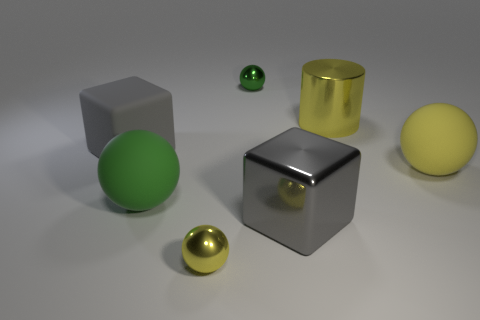How many other big yellow cylinders have the same material as the cylinder?
Provide a short and direct response. 0. There is another green metallic thing that is the same shape as the large green object; what is its size?
Offer a very short reply. Small. Are there any large cubes in front of the tiny yellow object?
Offer a terse response. No. What material is the big green ball?
Give a very brief answer. Rubber. Is the color of the tiny thing in front of the big gray metallic block the same as the big matte block?
Make the answer very short. No. Is there anything else that has the same shape as the large green rubber thing?
Make the answer very short. Yes. There is another big rubber object that is the same shape as the big yellow rubber thing; what is its color?
Offer a very short reply. Green. There is a gray object behind the yellow rubber object; what is its material?
Make the answer very short. Rubber. The big metallic cube has what color?
Offer a terse response. Gray. Do the yellow sphere behind the gray metallic block and the small yellow sphere have the same size?
Your answer should be compact. No. 